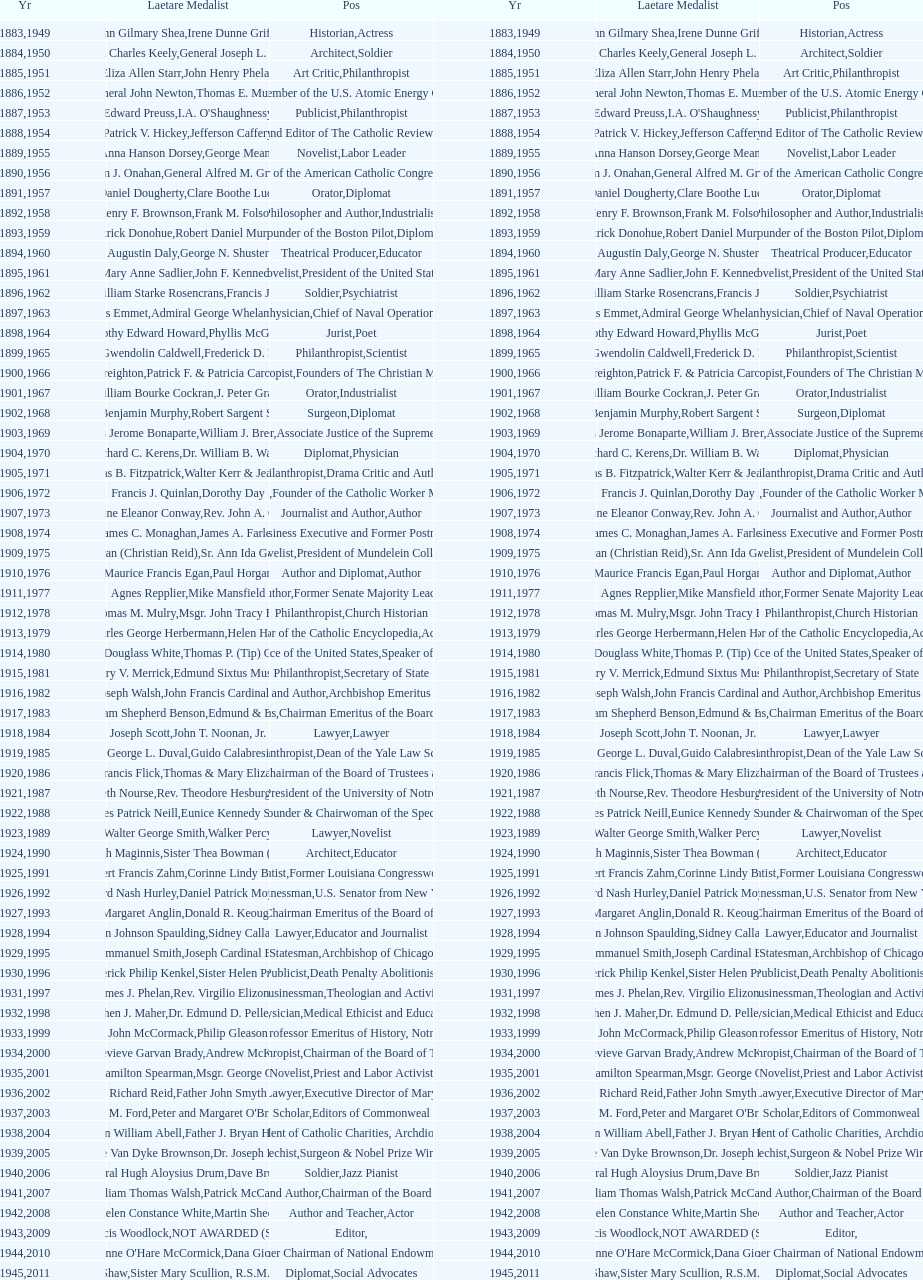Who won the medal after thomas e. murray in 1952? I.A. O'Shaughnessy. 